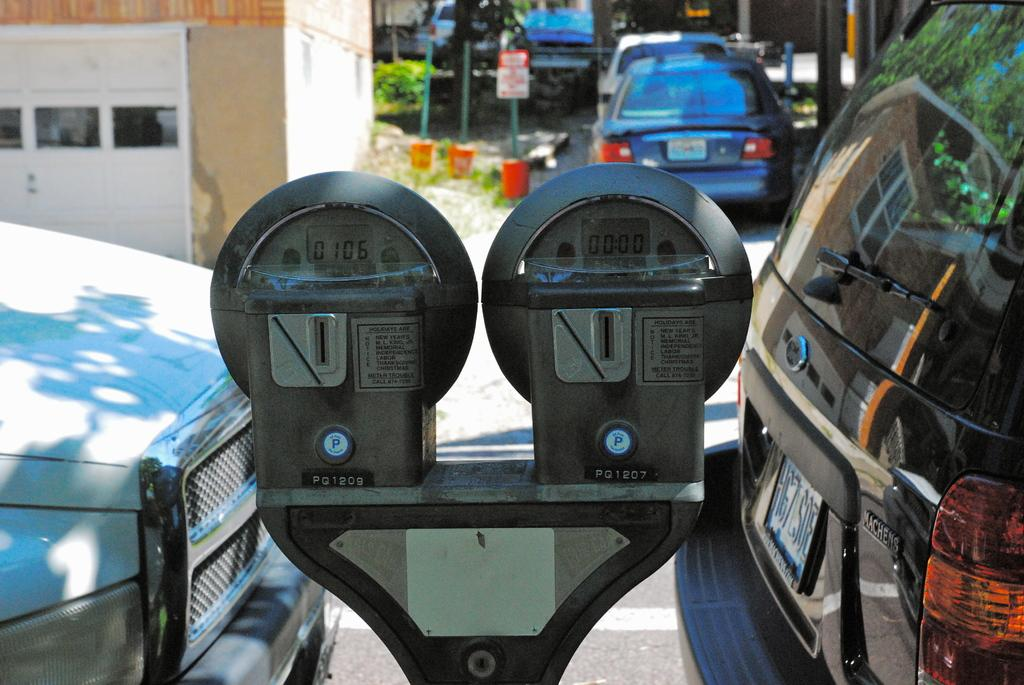<image>
Describe the image concisely. A duel parking meter with the left one reading 0106 on it's digital display. 